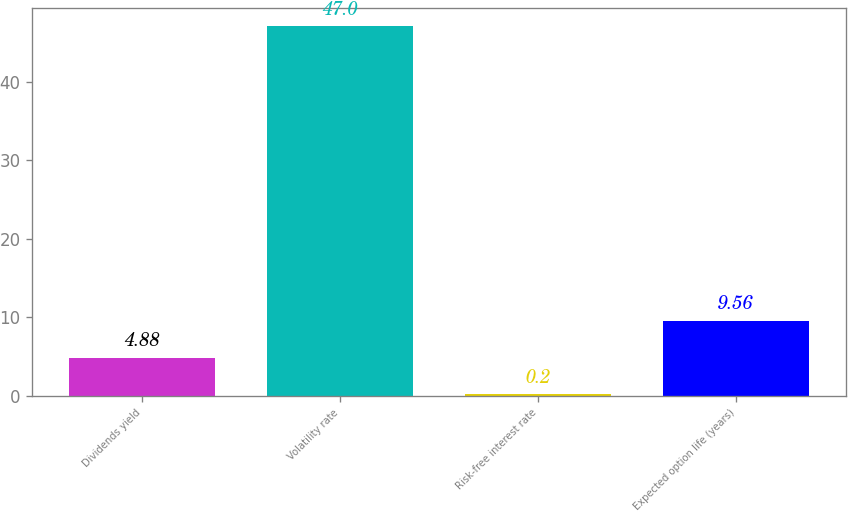Convert chart to OTSL. <chart><loc_0><loc_0><loc_500><loc_500><bar_chart><fcel>Dividends yield<fcel>Volatility rate<fcel>Risk-free interest rate<fcel>Expected option life (years)<nl><fcel>4.88<fcel>47<fcel>0.2<fcel>9.56<nl></chart> 